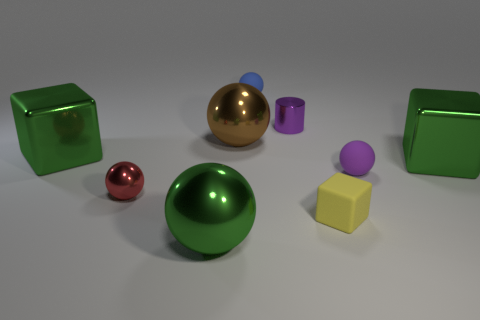Add 1 red metallic blocks. How many objects exist? 10 Subtract all big shiny cubes. How many cubes are left? 1 Subtract all purple rubber spheres. Subtract all tiny purple cylinders. How many objects are left? 7 Add 8 small cylinders. How many small cylinders are left? 9 Add 3 small blue rubber cubes. How many small blue rubber cubes exist? 3 Subtract all green cubes. How many cubes are left? 1 Subtract 0 green cylinders. How many objects are left? 9 Subtract all balls. How many objects are left? 4 Subtract 1 cylinders. How many cylinders are left? 0 Subtract all gray cubes. Subtract all cyan cylinders. How many cubes are left? 3 